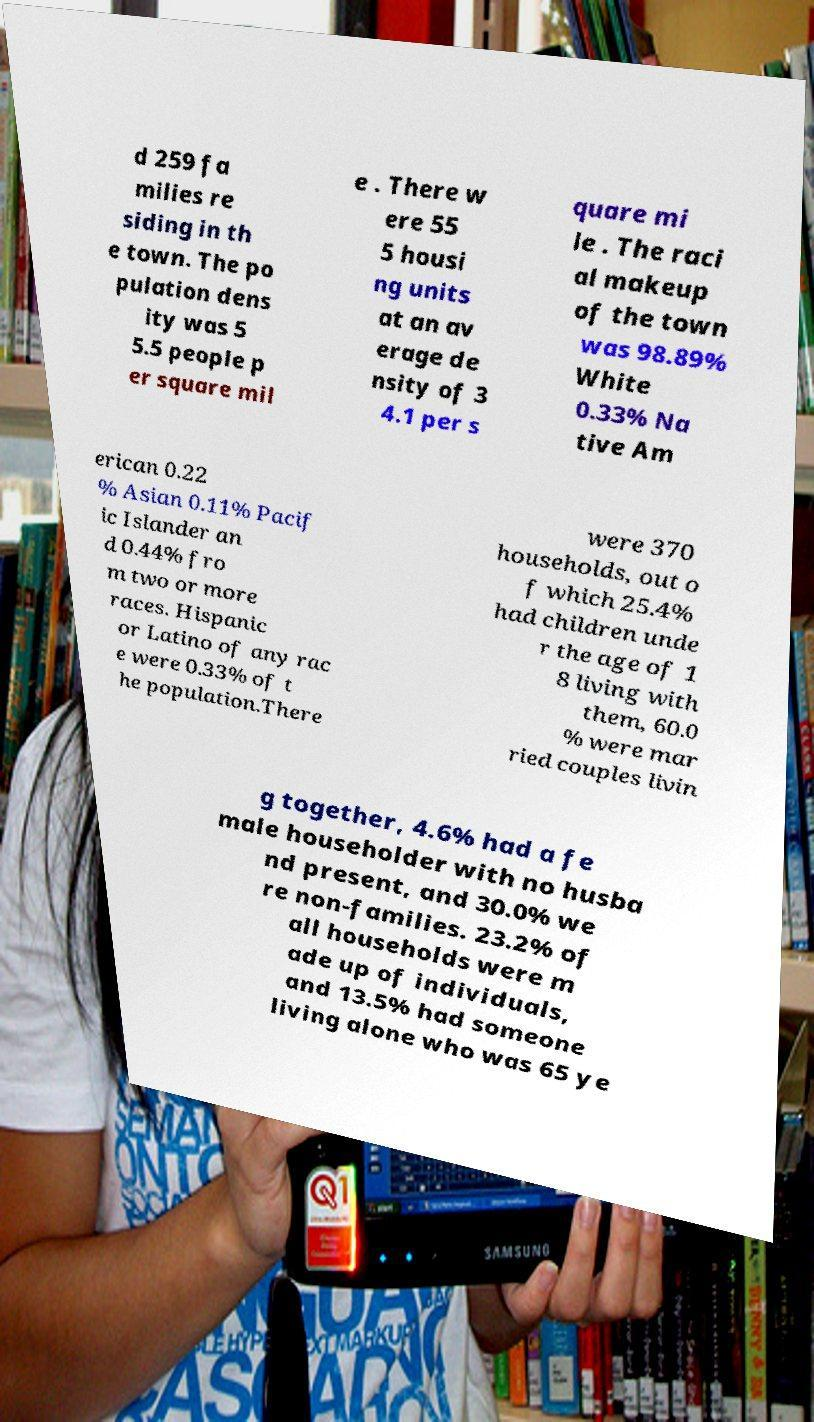Please identify and transcribe the text found in this image. d 259 fa milies re siding in th e town. The po pulation dens ity was 5 5.5 people p er square mil e . There w ere 55 5 housi ng units at an av erage de nsity of 3 4.1 per s quare mi le . The raci al makeup of the town was 98.89% White 0.33% Na tive Am erican 0.22 % Asian 0.11% Pacif ic Islander an d 0.44% fro m two or more races. Hispanic or Latino of any rac e were 0.33% of t he population.There were 370 households, out o f which 25.4% had children unde r the age of 1 8 living with them, 60.0 % were mar ried couples livin g together, 4.6% had a fe male householder with no husba nd present, and 30.0% we re non-families. 23.2% of all households were m ade up of individuals, and 13.5% had someone living alone who was 65 ye 